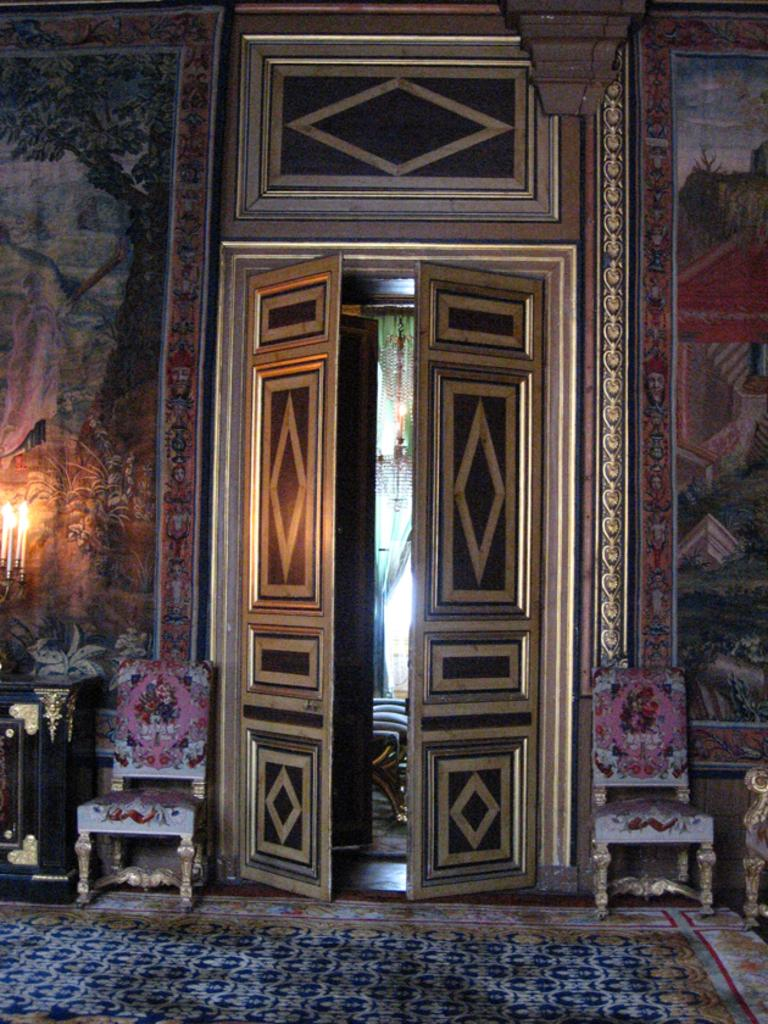What can be seen in the middle of the image? There are two doors in the middle of the image. What is located on either side of the doors? There is a chair on the right side of the doors and a chair on the left side of the doors. What is covering the floor in the image? There is a carpet on the floor. How would you describe the wall in the image? The wall is colorful. How many oranges are hanging from the ceiling in the image? There are no oranges present in the image. What type of rainstorm can be seen through the windows in the image? There are no windows or rainstorms depicted in the image. 